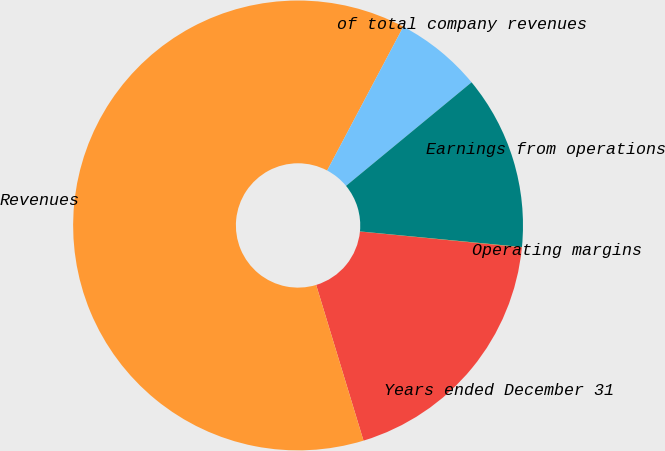Convert chart to OTSL. <chart><loc_0><loc_0><loc_500><loc_500><pie_chart><fcel>Years ended December 31<fcel>Revenues<fcel>of total company revenues<fcel>Earnings from operations<fcel>Operating margins<nl><fcel>18.75%<fcel>62.45%<fcel>6.27%<fcel>12.51%<fcel>0.02%<nl></chart> 